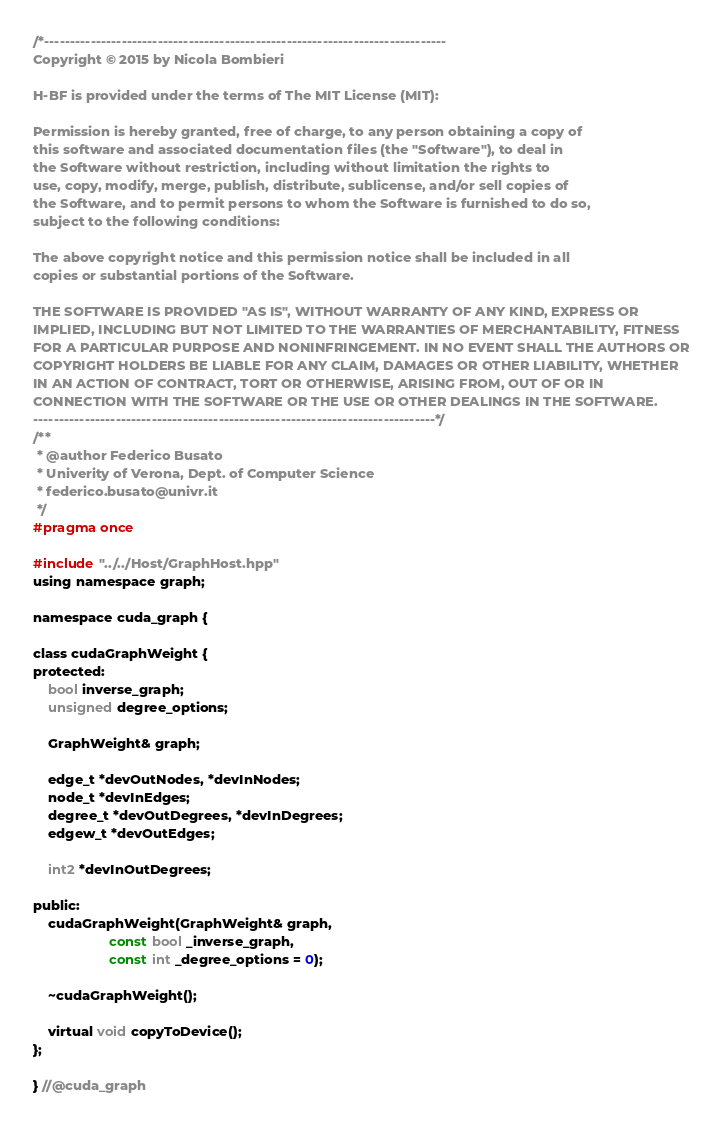<code> <loc_0><loc_0><loc_500><loc_500><_Cuda_>/*------------------------------------------------------------------------------
Copyright © 2015 by Nicola Bombieri

H-BF is provided under the terms of The MIT License (MIT):

Permission is hereby granted, free of charge, to any person obtaining a copy of
this software and associated documentation files (the "Software"), to deal in
the Software without restriction, including without limitation the rights to
use, copy, modify, merge, publish, distribute, sublicense, and/or sell copies of
the Software, and to permit persons to whom the Software is furnished to do so,
subject to the following conditions:

The above copyright notice and this permission notice shall be included in all
copies or substantial portions of the Software.

THE SOFTWARE IS PROVIDED "AS IS", WITHOUT WARRANTY OF ANY KIND, EXPRESS OR
IMPLIED, INCLUDING BUT NOT LIMITED TO THE WARRANTIES OF MERCHANTABILITY, FITNESS
FOR A PARTICULAR PURPOSE AND NONINFRINGEMENT. IN NO EVENT SHALL THE AUTHORS OR
COPYRIGHT HOLDERS BE LIABLE FOR ANY CLAIM, DAMAGES OR OTHER LIABILITY, WHETHER
IN AN ACTION OF CONTRACT, TORT OR OTHERWISE, ARISING FROM, OUT OF OR IN
CONNECTION WITH THE SOFTWARE OR THE USE OR OTHER DEALINGS IN THE SOFTWARE.
------------------------------------------------------------------------------*/
/**
 * @author Federico Busato
 * Univerity of Verona, Dept. of Computer Science
 * federico.busato@univr.it
 */
#pragma once

#include "../../Host/GraphHost.hpp"
using namespace graph;

namespace cuda_graph {

class cudaGraphWeight {
protected:
    bool inverse_graph;
    unsigned degree_options;

    GraphWeight& graph;

    edge_t *devOutNodes, *devInNodes;
    node_t *devInEdges;
    degree_t *devOutDegrees, *devInDegrees;
    edgew_t *devOutEdges;

    int2 *devInOutDegrees;

public:
    cudaGraphWeight(GraphWeight& graph,
                    const bool _inverse_graph,
                    const int _degree_options = 0);

    ~cudaGraphWeight();

    virtual void copyToDevice();
};

} //@cuda_graph
</code> 